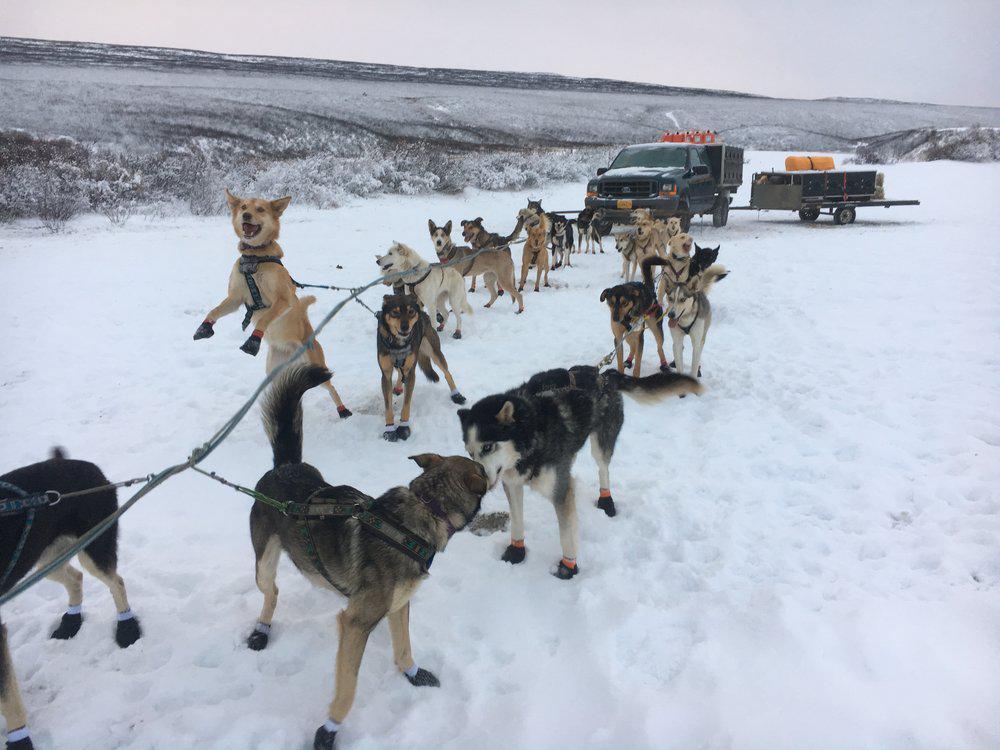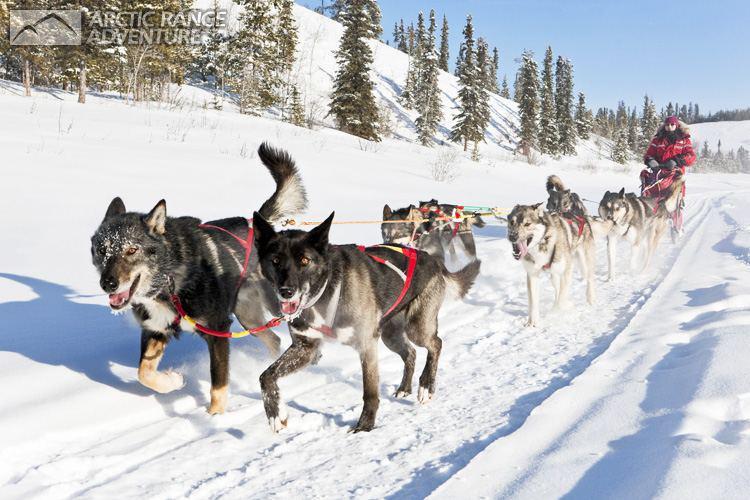The first image is the image on the left, the second image is the image on the right. Analyze the images presented: Is the assertion "In at least one image there is a person in blue in the sled and a person in red behind the sled." valid? Answer yes or no. No. The first image is the image on the left, the second image is the image on the right. For the images shown, is this caption "Some dogs are resting." true? Answer yes or no. Yes. 